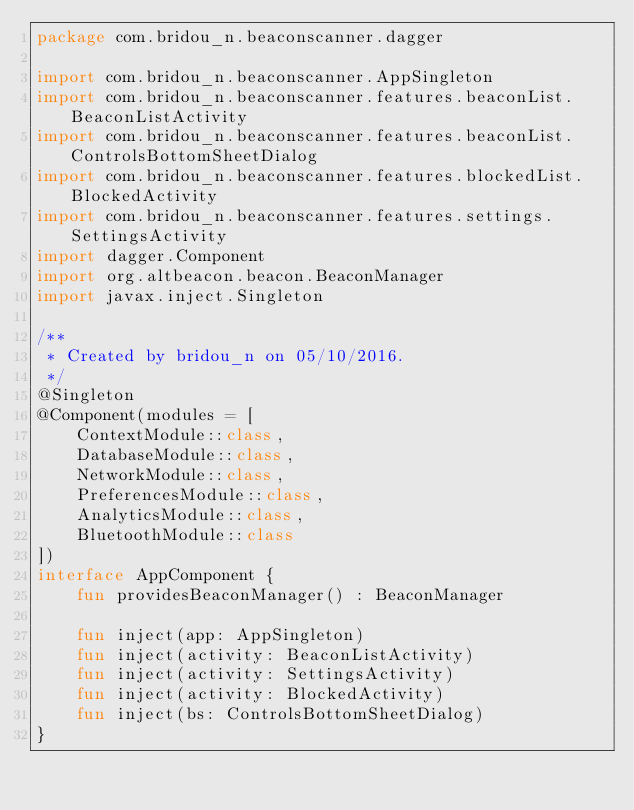Convert code to text. <code><loc_0><loc_0><loc_500><loc_500><_Kotlin_>package com.bridou_n.beaconscanner.dagger

import com.bridou_n.beaconscanner.AppSingleton
import com.bridou_n.beaconscanner.features.beaconList.BeaconListActivity
import com.bridou_n.beaconscanner.features.beaconList.ControlsBottomSheetDialog
import com.bridou_n.beaconscanner.features.blockedList.BlockedActivity
import com.bridou_n.beaconscanner.features.settings.SettingsActivity
import dagger.Component
import org.altbeacon.beacon.BeaconManager
import javax.inject.Singleton

/**
 * Created by bridou_n on 05/10/2016.
 */
@Singleton
@Component(modules = [
    ContextModule::class,
    DatabaseModule::class,
    NetworkModule::class,
    PreferencesModule::class,
    AnalyticsModule::class,
    BluetoothModule::class
])
interface AppComponent {
    fun providesBeaconManager() : BeaconManager

    fun inject(app: AppSingleton)
    fun inject(activity: BeaconListActivity)
    fun inject(activity: SettingsActivity)
    fun inject(activity: BlockedActivity)
    fun inject(bs: ControlsBottomSheetDialog)
}
</code> 